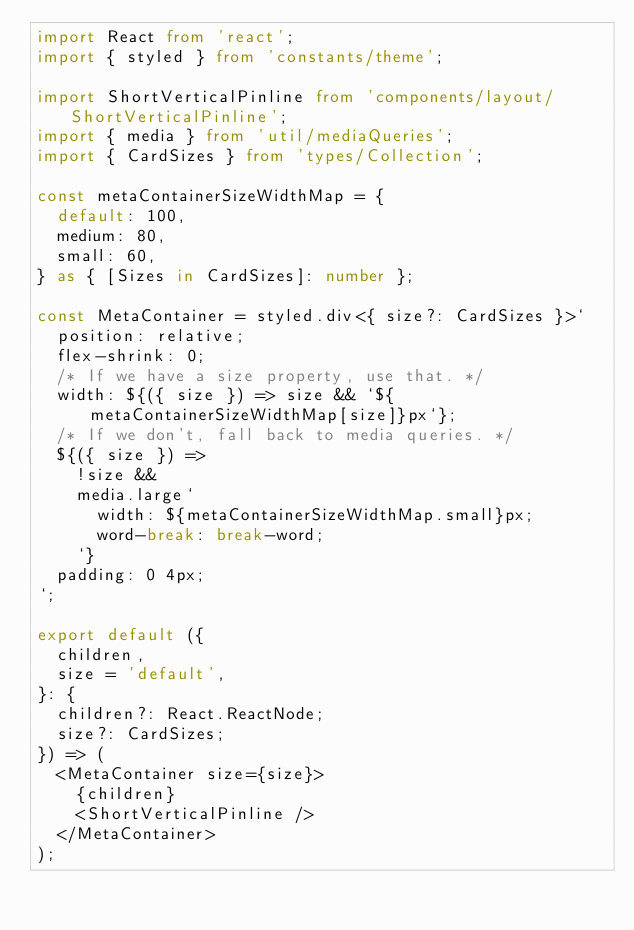Convert code to text. <code><loc_0><loc_0><loc_500><loc_500><_TypeScript_>import React from 'react';
import { styled } from 'constants/theme';

import ShortVerticalPinline from 'components/layout/ShortVerticalPinline';
import { media } from 'util/mediaQueries';
import { CardSizes } from 'types/Collection';

const metaContainerSizeWidthMap = {
  default: 100,
  medium: 80,
  small: 60,
} as { [Sizes in CardSizes]: number };

const MetaContainer = styled.div<{ size?: CardSizes }>`
  position: relative;
  flex-shrink: 0;
  /* If we have a size property, use that. */
  width: ${({ size }) => size && `${metaContainerSizeWidthMap[size]}px`};
  /* If we don't, fall back to media queries. */
  ${({ size }) =>
    !size &&
    media.large`
      width: ${metaContainerSizeWidthMap.small}px;
      word-break: break-word;
    `}
  padding: 0 4px;
`;

export default ({
  children,
  size = 'default',
}: {
  children?: React.ReactNode;
  size?: CardSizes;
}) => (
  <MetaContainer size={size}>
    {children}
    <ShortVerticalPinline />
  </MetaContainer>
);
</code> 